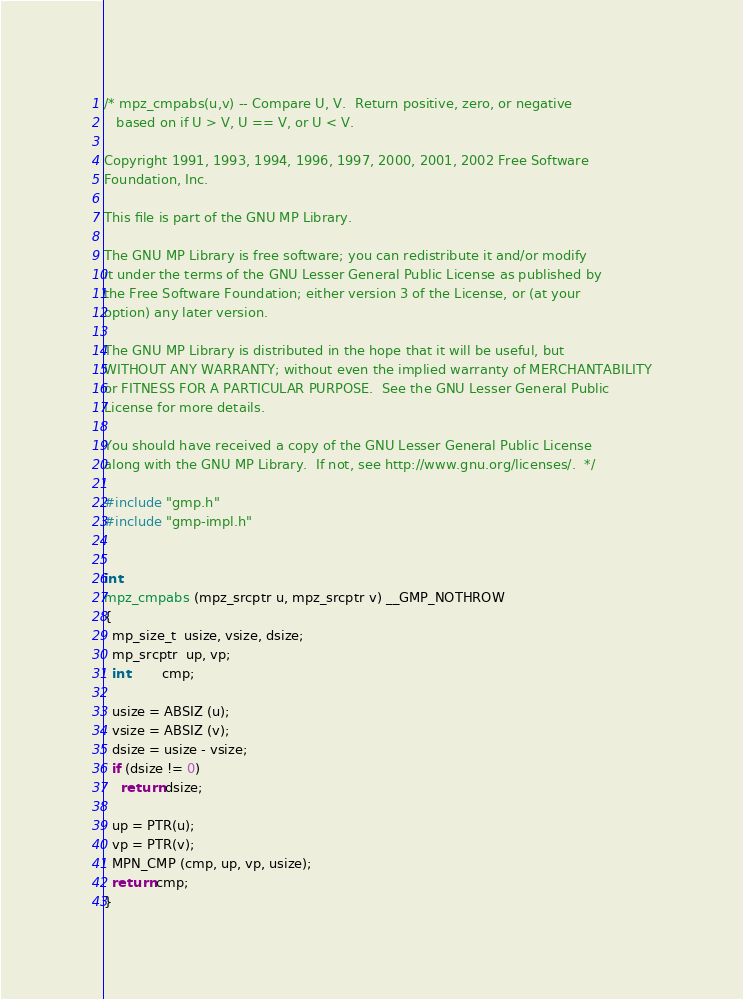<code> <loc_0><loc_0><loc_500><loc_500><_C_>/* mpz_cmpabs(u,v) -- Compare U, V.  Return positive, zero, or negative
   based on if U > V, U == V, or U < V.

Copyright 1991, 1993, 1994, 1996, 1997, 2000, 2001, 2002 Free Software
Foundation, Inc.

This file is part of the GNU MP Library.

The GNU MP Library is free software; you can redistribute it and/or modify
it under the terms of the GNU Lesser General Public License as published by
the Free Software Foundation; either version 3 of the License, or (at your
option) any later version.

The GNU MP Library is distributed in the hope that it will be useful, but
WITHOUT ANY WARRANTY; without even the implied warranty of MERCHANTABILITY
or FITNESS FOR A PARTICULAR PURPOSE.  See the GNU Lesser General Public
License for more details.

You should have received a copy of the GNU Lesser General Public License
along with the GNU MP Library.  If not, see http://www.gnu.org/licenses/.  */

#include "gmp.h"
#include "gmp-impl.h"


int
mpz_cmpabs (mpz_srcptr u, mpz_srcptr v) __GMP_NOTHROW
{
  mp_size_t  usize, vsize, dsize;
  mp_srcptr  up, vp;
  int        cmp;

  usize = ABSIZ (u);
  vsize = ABSIZ (v);
  dsize = usize - vsize;
  if (dsize != 0)
    return dsize;

  up = PTR(u);
  vp = PTR(v);
  MPN_CMP (cmp, up, vp, usize);
  return cmp;
}
</code> 